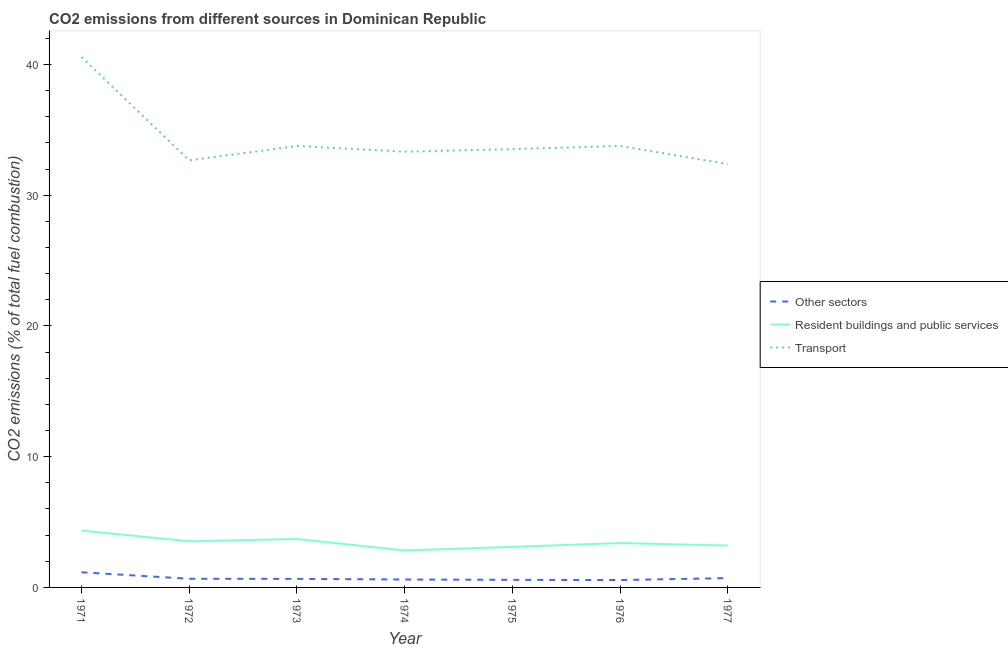Does the line corresponding to percentage of co2 emissions from transport intersect with the line corresponding to percentage of co2 emissions from other sectors?
Ensure brevity in your answer.  No. What is the percentage of co2 emissions from resident buildings and public services in 1972?
Provide a succinct answer. 3.53. Across all years, what is the maximum percentage of co2 emissions from resident buildings and public services?
Offer a terse response. 4.35. Across all years, what is the minimum percentage of co2 emissions from other sectors?
Offer a terse response. 0.57. In which year was the percentage of co2 emissions from transport minimum?
Provide a succinct answer. 1977. What is the total percentage of co2 emissions from transport in the graph?
Provide a short and direct response. 240.04. What is the difference between the percentage of co2 emissions from transport in 1974 and that in 1977?
Provide a short and direct response. 0.95. What is the difference between the percentage of co2 emissions from transport in 1971 and the percentage of co2 emissions from other sectors in 1973?
Keep it short and to the point. 39.93. What is the average percentage of co2 emissions from resident buildings and public services per year?
Keep it short and to the point. 3.44. In the year 1973, what is the difference between the percentage of co2 emissions from resident buildings and public services and percentage of co2 emissions from other sectors?
Give a very brief answer. 3.05. What is the ratio of the percentage of co2 emissions from transport in 1972 to that in 1974?
Provide a short and direct response. 0.98. Is the difference between the percentage of co2 emissions from resident buildings and public services in 1975 and 1976 greater than the difference between the percentage of co2 emissions from transport in 1975 and 1976?
Your response must be concise. No. What is the difference between the highest and the second highest percentage of co2 emissions from resident buildings and public services?
Offer a terse response. 0.64. What is the difference between the highest and the lowest percentage of co2 emissions from other sectors?
Ensure brevity in your answer.  0.59. In how many years, is the percentage of co2 emissions from transport greater than the average percentage of co2 emissions from transport taken over all years?
Your answer should be compact. 1. Is the sum of the percentage of co2 emissions from other sectors in 1971 and 1977 greater than the maximum percentage of co2 emissions from resident buildings and public services across all years?
Keep it short and to the point. No. Is it the case that in every year, the sum of the percentage of co2 emissions from other sectors and percentage of co2 emissions from resident buildings and public services is greater than the percentage of co2 emissions from transport?
Ensure brevity in your answer.  No. Is the percentage of co2 emissions from resident buildings and public services strictly greater than the percentage of co2 emissions from other sectors over the years?
Give a very brief answer. Yes. How many lines are there?
Offer a terse response. 3. How many years are there in the graph?
Offer a very short reply. 7. Are the values on the major ticks of Y-axis written in scientific E-notation?
Provide a succinct answer. No. Does the graph contain any zero values?
Your answer should be compact. No. Does the graph contain grids?
Your response must be concise. No. Where does the legend appear in the graph?
Offer a terse response. Center right. How are the legend labels stacked?
Give a very brief answer. Vertical. What is the title of the graph?
Offer a terse response. CO2 emissions from different sources in Dominican Republic. What is the label or title of the Y-axis?
Provide a succinct answer. CO2 emissions (% of total fuel combustion). What is the CO2 emissions (% of total fuel combustion) in Other sectors in 1971?
Keep it short and to the point. 1.16. What is the CO2 emissions (% of total fuel combustion) in Resident buildings and public services in 1971?
Keep it short and to the point. 4.35. What is the CO2 emissions (% of total fuel combustion) in Transport in 1971?
Your answer should be very brief. 40.58. What is the CO2 emissions (% of total fuel combustion) of Other sectors in 1972?
Provide a short and direct response. 0.66. What is the CO2 emissions (% of total fuel combustion) of Resident buildings and public services in 1972?
Your response must be concise. 3.53. What is the CO2 emissions (% of total fuel combustion) in Transport in 1972?
Offer a terse response. 32.67. What is the CO2 emissions (% of total fuel combustion) of Other sectors in 1973?
Provide a short and direct response. 0.65. What is the CO2 emissions (% of total fuel combustion) in Resident buildings and public services in 1973?
Give a very brief answer. 3.7. What is the CO2 emissions (% of total fuel combustion) of Transport in 1973?
Ensure brevity in your answer.  33.77. What is the CO2 emissions (% of total fuel combustion) of Other sectors in 1974?
Ensure brevity in your answer.  0.61. What is the CO2 emissions (% of total fuel combustion) in Resident buildings and public services in 1974?
Ensure brevity in your answer.  2.83. What is the CO2 emissions (% of total fuel combustion) in Transport in 1974?
Offer a very short reply. 33.33. What is the CO2 emissions (% of total fuel combustion) in Other sectors in 1975?
Offer a very short reply. 0.58. What is the CO2 emissions (% of total fuel combustion) of Resident buildings and public services in 1975?
Keep it short and to the point. 3.1. What is the CO2 emissions (% of total fuel combustion) of Transport in 1975?
Provide a succinct answer. 33.53. What is the CO2 emissions (% of total fuel combustion) of Other sectors in 1976?
Your answer should be very brief. 0.57. What is the CO2 emissions (% of total fuel combustion) in Resident buildings and public services in 1976?
Give a very brief answer. 3.4. What is the CO2 emissions (% of total fuel combustion) of Transport in 1976?
Keep it short and to the point. 33.77. What is the CO2 emissions (% of total fuel combustion) of Other sectors in 1977?
Provide a succinct answer. 0.71. What is the CO2 emissions (% of total fuel combustion) of Resident buildings and public services in 1977?
Your response must be concise. 3.2. What is the CO2 emissions (% of total fuel combustion) in Transport in 1977?
Provide a succinct answer. 32.38. Across all years, what is the maximum CO2 emissions (% of total fuel combustion) in Other sectors?
Give a very brief answer. 1.16. Across all years, what is the maximum CO2 emissions (% of total fuel combustion) of Resident buildings and public services?
Your answer should be compact. 4.35. Across all years, what is the maximum CO2 emissions (% of total fuel combustion) of Transport?
Ensure brevity in your answer.  40.58. Across all years, what is the minimum CO2 emissions (% of total fuel combustion) of Other sectors?
Give a very brief answer. 0.57. Across all years, what is the minimum CO2 emissions (% of total fuel combustion) in Resident buildings and public services?
Offer a very short reply. 2.83. Across all years, what is the minimum CO2 emissions (% of total fuel combustion) of Transport?
Offer a very short reply. 32.38. What is the total CO2 emissions (% of total fuel combustion) in Other sectors in the graph?
Offer a very short reply. 4.94. What is the total CO2 emissions (% of total fuel combustion) of Resident buildings and public services in the graph?
Your answer should be compact. 24.11. What is the total CO2 emissions (% of total fuel combustion) in Transport in the graph?
Provide a short and direct response. 240.04. What is the difference between the CO2 emissions (% of total fuel combustion) of Other sectors in 1971 and that in 1972?
Offer a very short reply. 0.5. What is the difference between the CO2 emissions (% of total fuel combustion) of Resident buildings and public services in 1971 and that in 1972?
Keep it short and to the point. 0.82. What is the difference between the CO2 emissions (% of total fuel combustion) of Transport in 1971 and that in 1972?
Your answer should be very brief. 7.91. What is the difference between the CO2 emissions (% of total fuel combustion) of Other sectors in 1971 and that in 1973?
Your response must be concise. 0.51. What is the difference between the CO2 emissions (% of total fuel combustion) of Resident buildings and public services in 1971 and that in 1973?
Provide a short and direct response. 0.64. What is the difference between the CO2 emissions (% of total fuel combustion) of Transport in 1971 and that in 1973?
Provide a short and direct response. 6.81. What is the difference between the CO2 emissions (% of total fuel combustion) in Other sectors in 1971 and that in 1974?
Your answer should be very brief. 0.55. What is the difference between the CO2 emissions (% of total fuel combustion) of Resident buildings and public services in 1971 and that in 1974?
Provide a short and direct response. 1.52. What is the difference between the CO2 emissions (% of total fuel combustion) in Transport in 1971 and that in 1974?
Your answer should be very brief. 7.25. What is the difference between the CO2 emissions (% of total fuel combustion) in Other sectors in 1971 and that in 1975?
Provide a succinct answer. 0.58. What is the difference between the CO2 emissions (% of total fuel combustion) of Resident buildings and public services in 1971 and that in 1975?
Your answer should be very brief. 1.25. What is the difference between the CO2 emissions (% of total fuel combustion) in Transport in 1971 and that in 1975?
Give a very brief answer. 7.05. What is the difference between the CO2 emissions (% of total fuel combustion) in Other sectors in 1971 and that in 1976?
Offer a terse response. 0.59. What is the difference between the CO2 emissions (% of total fuel combustion) of Resident buildings and public services in 1971 and that in 1976?
Make the answer very short. 0.95. What is the difference between the CO2 emissions (% of total fuel combustion) in Transport in 1971 and that in 1976?
Offer a terse response. 6.81. What is the difference between the CO2 emissions (% of total fuel combustion) in Other sectors in 1971 and that in 1977?
Make the answer very short. 0.45. What is the difference between the CO2 emissions (% of total fuel combustion) in Resident buildings and public services in 1971 and that in 1977?
Your answer should be very brief. 1.15. What is the difference between the CO2 emissions (% of total fuel combustion) in Transport in 1971 and that in 1977?
Give a very brief answer. 8.2. What is the difference between the CO2 emissions (% of total fuel combustion) in Other sectors in 1972 and that in 1973?
Your answer should be compact. 0.01. What is the difference between the CO2 emissions (% of total fuel combustion) in Resident buildings and public services in 1972 and that in 1973?
Give a very brief answer. -0.17. What is the difference between the CO2 emissions (% of total fuel combustion) of Transport in 1972 and that in 1973?
Your answer should be compact. -1.1. What is the difference between the CO2 emissions (% of total fuel combustion) of Other sectors in 1972 and that in 1974?
Ensure brevity in your answer.  0.06. What is the difference between the CO2 emissions (% of total fuel combustion) in Resident buildings and public services in 1972 and that in 1974?
Ensure brevity in your answer.  0.7. What is the difference between the CO2 emissions (% of total fuel combustion) in Transport in 1972 and that in 1974?
Ensure brevity in your answer.  -0.66. What is the difference between the CO2 emissions (% of total fuel combustion) in Other sectors in 1972 and that in 1975?
Make the answer very short. 0.08. What is the difference between the CO2 emissions (% of total fuel combustion) of Resident buildings and public services in 1972 and that in 1975?
Provide a short and direct response. 0.43. What is the difference between the CO2 emissions (% of total fuel combustion) of Transport in 1972 and that in 1975?
Give a very brief answer. -0.86. What is the difference between the CO2 emissions (% of total fuel combustion) of Other sectors in 1972 and that in 1976?
Offer a very short reply. 0.1. What is the difference between the CO2 emissions (% of total fuel combustion) in Resident buildings and public services in 1972 and that in 1976?
Your answer should be very brief. 0.14. What is the difference between the CO2 emissions (% of total fuel combustion) of Transport in 1972 and that in 1976?
Your response must be concise. -1.1. What is the difference between the CO2 emissions (% of total fuel combustion) of Other sectors in 1972 and that in 1977?
Give a very brief answer. -0.05. What is the difference between the CO2 emissions (% of total fuel combustion) of Resident buildings and public services in 1972 and that in 1977?
Offer a very short reply. 0.33. What is the difference between the CO2 emissions (% of total fuel combustion) of Transport in 1972 and that in 1977?
Give a very brief answer. 0.29. What is the difference between the CO2 emissions (% of total fuel combustion) of Other sectors in 1973 and that in 1974?
Provide a succinct answer. 0.05. What is the difference between the CO2 emissions (% of total fuel combustion) in Resident buildings and public services in 1973 and that in 1974?
Keep it short and to the point. 0.88. What is the difference between the CO2 emissions (% of total fuel combustion) of Transport in 1973 and that in 1974?
Your answer should be compact. 0.44. What is the difference between the CO2 emissions (% of total fuel combustion) in Other sectors in 1973 and that in 1975?
Offer a terse response. 0.07. What is the difference between the CO2 emissions (% of total fuel combustion) in Resident buildings and public services in 1973 and that in 1975?
Your answer should be very brief. 0.6. What is the difference between the CO2 emissions (% of total fuel combustion) in Transport in 1973 and that in 1975?
Offer a very short reply. 0.24. What is the difference between the CO2 emissions (% of total fuel combustion) of Other sectors in 1973 and that in 1976?
Your answer should be compact. 0.09. What is the difference between the CO2 emissions (% of total fuel combustion) in Resident buildings and public services in 1973 and that in 1976?
Offer a terse response. 0.31. What is the difference between the CO2 emissions (% of total fuel combustion) of Transport in 1973 and that in 1976?
Ensure brevity in your answer.  -0. What is the difference between the CO2 emissions (% of total fuel combustion) of Other sectors in 1973 and that in 1977?
Provide a succinct answer. -0.06. What is the difference between the CO2 emissions (% of total fuel combustion) in Resident buildings and public services in 1973 and that in 1977?
Your response must be concise. 0.5. What is the difference between the CO2 emissions (% of total fuel combustion) of Transport in 1973 and that in 1977?
Provide a short and direct response. 1.38. What is the difference between the CO2 emissions (% of total fuel combustion) in Other sectors in 1974 and that in 1975?
Give a very brief answer. 0.02. What is the difference between the CO2 emissions (% of total fuel combustion) of Resident buildings and public services in 1974 and that in 1975?
Ensure brevity in your answer.  -0.27. What is the difference between the CO2 emissions (% of total fuel combustion) in Transport in 1974 and that in 1975?
Offer a terse response. -0.19. What is the difference between the CO2 emissions (% of total fuel combustion) of Resident buildings and public services in 1974 and that in 1976?
Provide a short and direct response. -0.57. What is the difference between the CO2 emissions (% of total fuel combustion) in Transport in 1974 and that in 1976?
Offer a terse response. -0.44. What is the difference between the CO2 emissions (% of total fuel combustion) in Other sectors in 1974 and that in 1977?
Ensure brevity in your answer.  -0.11. What is the difference between the CO2 emissions (% of total fuel combustion) in Resident buildings and public services in 1974 and that in 1977?
Offer a terse response. -0.37. What is the difference between the CO2 emissions (% of total fuel combustion) in Transport in 1974 and that in 1977?
Give a very brief answer. 0.95. What is the difference between the CO2 emissions (% of total fuel combustion) in Other sectors in 1975 and that in 1976?
Your response must be concise. 0.02. What is the difference between the CO2 emissions (% of total fuel combustion) in Resident buildings and public services in 1975 and that in 1976?
Ensure brevity in your answer.  -0.3. What is the difference between the CO2 emissions (% of total fuel combustion) of Transport in 1975 and that in 1976?
Your answer should be compact. -0.25. What is the difference between the CO2 emissions (% of total fuel combustion) in Other sectors in 1975 and that in 1977?
Keep it short and to the point. -0.13. What is the difference between the CO2 emissions (% of total fuel combustion) of Resident buildings and public services in 1975 and that in 1977?
Keep it short and to the point. -0.1. What is the difference between the CO2 emissions (% of total fuel combustion) of Transport in 1975 and that in 1977?
Your response must be concise. 1.14. What is the difference between the CO2 emissions (% of total fuel combustion) of Other sectors in 1976 and that in 1977?
Provide a short and direct response. -0.15. What is the difference between the CO2 emissions (% of total fuel combustion) of Resident buildings and public services in 1976 and that in 1977?
Your response must be concise. 0.19. What is the difference between the CO2 emissions (% of total fuel combustion) of Transport in 1976 and that in 1977?
Make the answer very short. 1.39. What is the difference between the CO2 emissions (% of total fuel combustion) of Other sectors in 1971 and the CO2 emissions (% of total fuel combustion) of Resident buildings and public services in 1972?
Your answer should be compact. -2.37. What is the difference between the CO2 emissions (% of total fuel combustion) of Other sectors in 1971 and the CO2 emissions (% of total fuel combustion) of Transport in 1972?
Ensure brevity in your answer.  -31.51. What is the difference between the CO2 emissions (% of total fuel combustion) in Resident buildings and public services in 1971 and the CO2 emissions (% of total fuel combustion) in Transport in 1972?
Your response must be concise. -28.32. What is the difference between the CO2 emissions (% of total fuel combustion) in Other sectors in 1971 and the CO2 emissions (% of total fuel combustion) in Resident buildings and public services in 1973?
Your answer should be very brief. -2.54. What is the difference between the CO2 emissions (% of total fuel combustion) of Other sectors in 1971 and the CO2 emissions (% of total fuel combustion) of Transport in 1973?
Your answer should be compact. -32.61. What is the difference between the CO2 emissions (% of total fuel combustion) of Resident buildings and public services in 1971 and the CO2 emissions (% of total fuel combustion) of Transport in 1973?
Your response must be concise. -29.42. What is the difference between the CO2 emissions (% of total fuel combustion) in Other sectors in 1971 and the CO2 emissions (% of total fuel combustion) in Resident buildings and public services in 1974?
Make the answer very short. -1.67. What is the difference between the CO2 emissions (% of total fuel combustion) of Other sectors in 1971 and the CO2 emissions (% of total fuel combustion) of Transport in 1974?
Keep it short and to the point. -32.17. What is the difference between the CO2 emissions (% of total fuel combustion) in Resident buildings and public services in 1971 and the CO2 emissions (% of total fuel combustion) in Transport in 1974?
Give a very brief answer. -28.99. What is the difference between the CO2 emissions (% of total fuel combustion) of Other sectors in 1971 and the CO2 emissions (% of total fuel combustion) of Resident buildings and public services in 1975?
Provide a succinct answer. -1.94. What is the difference between the CO2 emissions (% of total fuel combustion) of Other sectors in 1971 and the CO2 emissions (% of total fuel combustion) of Transport in 1975?
Give a very brief answer. -32.37. What is the difference between the CO2 emissions (% of total fuel combustion) of Resident buildings and public services in 1971 and the CO2 emissions (% of total fuel combustion) of Transport in 1975?
Offer a terse response. -29.18. What is the difference between the CO2 emissions (% of total fuel combustion) in Other sectors in 1971 and the CO2 emissions (% of total fuel combustion) in Resident buildings and public services in 1976?
Your answer should be compact. -2.24. What is the difference between the CO2 emissions (% of total fuel combustion) in Other sectors in 1971 and the CO2 emissions (% of total fuel combustion) in Transport in 1976?
Offer a terse response. -32.61. What is the difference between the CO2 emissions (% of total fuel combustion) in Resident buildings and public services in 1971 and the CO2 emissions (% of total fuel combustion) in Transport in 1976?
Provide a short and direct response. -29.43. What is the difference between the CO2 emissions (% of total fuel combustion) in Other sectors in 1971 and the CO2 emissions (% of total fuel combustion) in Resident buildings and public services in 1977?
Ensure brevity in your answer.  -2.04. What is the difference between the CO2 emissions (% of total fuel combustion) of Other sectors in 1971 and the CO2 emissions (% of total fuel combustion) of Transport in 1977?
Provide a succinct answer. -31.22. What is the difference between the CO2 emissions (% of total fuel combustion) in Resident buildings and public services in 1971 and the CO2 emissions (% of total fuel combustion) in Transport in 1977?
Offer a very short reply. -28.04. What is the difference between the CO2 emissions (% of total fuel combustion) of Other sectors in 1972 and the CO2 emissions (% of total fuel combustion) of Resident buildings and public services in 1973?
Give a very brief answer. -3.04. What is the difference between the CO2 emissions (% of total fuel combustion) in Other sectors in 1972 and the CO2 emissions (% of total fuel combustion) in Transport in 1973?
Your response must be concise. -33.11. What is the difference between the CO2 emissions (% of total fuel combustion) of Resident buildings and public services in 1972 and the CO2 emissions (% of total fuel combustion) of Transport in 1973?
Ensure brevity in your answer.  -30.24. What is the difference between the CO2 emissions (% of total fuel combustion) of Other sectors in 1972 and the CO2 emissions (% of total fuel combustion) of Resident buildings and public services in 1974?
Your answer should be compact. -2.17. What is the difference between the CO2 emissions (% of total fuel combustion) in Other sectors in 1972 and the CO2 emissions (% of total fuel combustion) in Transport in 1974?
Ensure brevity in your answer.  -32.67. What is the difference between the CO2 emissions (% of total fuel combustion) in Resident buildings and public services in 1972 and the CO2 emissions (% of total fuel combustion) in Transport in 1974?
Provide a succinct answer. -29.8. What is the difference between the CO2 emissions (% of total fuel combustion) in Other sectors in 1972 and the CO2 emissions (% of total fuel combustion) in Resident buildings and public services in 1975?
Your response must be concise. -2.44. What is the difference between the CO2 emissions (% of total fuel combustion) in Other sectors in 1972 and the CO2 emissions (% of total fuel combustion) in Transport in 1975?
Offer a very short reply. -32.86. What is the difference between the CO2 emissions (% of total fuel combustion) of Resident buildings and public services in 1972 and the CO2 emissions (% of total fuel combustion) of Transport in 1975?
Provide a succinct answer. -30. What is the difference between the CO2 emissions (% of total fuel combustion) in Other sectors in 1972 and the CO2 emissions (% of total fuel combustion) in Resident buildings and public services in 1976?
Make the answer very short. -2.73. What is the difference between the CO2 emissions (% of total fuel combustion) in Other sectors in 1972 and the CO2 emissions (% of total fuel combustion) in Transport in 1976?
Provide a succinct answer. -33.11. What is the difference between the CO2 emissions (% of total fuel combustion) in Resident buildings and public services in 1972 and the CO2 emissions (% of total fuel combustion) in Transport in 1976?
Provide a short and direct response. -30.24. What is the difference between the CO2 emissions (% of total fuel combustion) of Other sectors in 1972 and the CO2 emissions (% of total fuel combustion) of Resident buildings and public services in 1977?
Give a very brief answer. -2.54. What is the difference between the CO2 emissions (% of total fuel combustion) of Other sectors in 1972 and the CO2 emissions (% of total fuel combustion) of Transport in 1977?
Offer a very short reply. -31.72. What is the difference between the CO2 emissions (% of total fuel combustion) of Resident buildings and public services in 1972 and the CO2 emissions (% of total fuel combustion) of Transport in 1977?
Provide a short and direct response. -28.85. What is the difference between the CO2 emissions (% of total fuel combustion) in Other sectors in 1973 and the CO2 emissions (% of total fuel combustion) in Resident buildings and public services in 1974?
Give a very brief answer. -2.17. What is the difference between the CO2 emissions (% of total fuel combustion) in Other sectors in 1973 and the CO2 emissions (% of total fuel combustion) in Transport in 1974?
Offer a terse response. -32.68. What is the difference between the CO2 emissions (% of total fuel combustion) of Resident buildings and public services in 1973 and the CO2 emissions (% of total fuel combustion) of Transport in 1974?
Your response must be concise. -29.63. What is the difference between the CO2 emissions (% of total fuel combustion) in Other sectors in 1973 and the CO2 emissions (% of total fuel combustion) in Resident buildings and public services in 1975?
Your response must be concise. -2.45. What is the difference between the CO2 emissions (% of total fuel combustion) of Other sectors in 1973 and the CO2 emissions (% of total fuel combustion) of Transport in 1975?
Provide a succinct answer. -32.87. What is the difference between the CO2 emissions (% of total fuel combustion) in Resident buildings and public services in 1973 and the CO2 emissions (% of total fuel combustion) in Transport in 1975?
Make the answer very short. -29.82. What is the difference between the CO2 emissions (% of total fuel combustion) in Other sectors in 1973 and the CO2 emissions (% of total fuel combustion) in Resident buildings and public services in 1976?
Your response must be concise. -2.74. What is the difference between the CO2 emissions (% of total fuel combustion) of Other sectors in 1973 and the CO2 emissions (% of total fuel combustion) of Transport in 1976?
Provide a short and direct response. -33.12. What is the difference between the CO2 emissions (% of total fuel combustion) of Resident buildings and public services in 1973 and the CO2 emissions (% of total fuel combustion) of Transport in 1976?
Your response must be concise. -30.07. What is the difference between the CO2 emissions (% of total fuel combustion) of Other sectors in 1973 and the CO2 emissions (% of total fuel combustion) of Resident buildings and public services in 1977?
Your answer should be compact. -2.55. What is the difference between the CO2 emissions (% of total fuel combustion) of Other sectors in 1973 and the CO2 emissions (% of total fuel combustion) of Transport in 1977?
Give a very brief answer. -31.73. What is the difference between the CO2 emissions (% of total fuel combustion) of Resident buildings and public services in 1973 and the CO2 emissions (% of total fuel combustion) of Transport in 1977?
Make the answer very short. -28.68. What is the difference between the CO2 emissions (% of total fuel combustion) in Other sectors in 1974 and the CO2 emissions (% of total fuel combustion) in Resident buildings and public services in 1975?
Offer a terse response. -2.49. What is the difference between the CO2 emissions (% of total fuel combustion) in Other sectors in 1974 and the CO2 emissions (% of total fuel combustion) in Transport in 1975?
Offer a very short reply. -32.92. What is the difference between the CO2 emissions (% of total fuel combustion) in Resident buildings and public services in 1974 and the CO2 emissions (% of total fuel combustion) in Transport in 1975?
Keep it short and to the point. -30.7. What is the difference between the CO2 emissions (% of total fuel combustion) of Other sectors in 1974 and the CO2 emissions (% of total fuel combustion) of Resident buildings and public services in 1976?
Offer a terse response. -2.79. What is the difference between the CO2 emissions (% of total fuel combustion) of Other sectors in 1974 and the CO2 emissions (% of total fuel combustion) of Transport in 1976?
Give a very brief answer. -33.17. What is the difference between the CO2 emissions (% of total fuel combustion) of Resident buildings and public services in 1974 and the CO2 emissions (% of total fuel combustion) of Transport in 1976?
Provide a short and direct response. -30.95. What is the difference between the CO2 emissions (% of total fuel combustion) in Other sectors in 1974 and the CO2 emissions (% of total fuel combustion) in Resident buildings and public services in 1977?
Offer a very short reply. -2.6. What is the difference between the CO2 emissions (% of total fuel combustion) of Other sectors in 1974 and the CO2 emissions (% of total fuel combustion) of Transport in 1977?
Ensure brevity in your answer.  -31.78. What is the difference between the CO2 emissions (% of total fuel combustion) of Resident buildings and public services in 1974 and the CO2 emissions (% of total fuel combustion) of Transport in 1977?
Keep it short and to the point. -29.56. What is the difference between the CO2 emissions (% of total fuel combustion) in Other sectors in 1975 and the CO2 emissions (% of total fuel combustion) in Resident buildings and public services in 1976?
Your answer should be very brief. -2.81. What is the difference between the CO2 emissions (% of total fuel combustion) in Other sectors in 1975 and the CO2 emissions (% of total fuel combustion) in Transport in 1976?
Ensure brevity in your answer.  -33.19. What is the difference between the CO2 emissions (% of total fuel combustion) of Resident buildings and public services in 1975 and the CO2 emissions (% of total fuel combustion) of Transport in 1976?
Make the answer very short. -30.67. What is the difference between the CO2 emissions (% of total fuel combustion) of Other sectors in 1975 and the CO2 emissions (% of total fuel combustion) of Resident buildings and public services in 1977?
Your answer should be very brief. -2.62. What is the difference between the CO2 emissions (% of total fuel combustion) in Other sectors in 1975 and the CO2 emissions (% of total fuel combustion) in Transport in 1977?
Your answer should be very brief. -31.8. What is the difference between the CO2 emissions (% of total fuel combustion) of Resident buildings and public services in 1975 and the CO2 emissions (% of total fuel combustion) of Transport in 1977?
Your answer should be compact. -29.28. What is the difference between the CO2 emissions (% of total fuel combustion) of Other sectors in 1976 and the CO2 emissions (% of total fuel combustion) of Resident buildings and public services in 1977?
Your answer should be very brief. -2.64. What is the difference between the CO2 emissions (% of total fuel combustion) in Other sectors in 1976 and the CO2 emissions (% of total fuel combustion) in Transport in 1977?
Your answer should be compact. -31.82. What is the difference between the CO2 emissions (% of total fuel combustion) in Resident buildings and public services in 1976 and the CO2 emissions (% of total fuel combustion) in Transport in 1977?
Your answer should be compact. -28.99. What is the average CO2 emissions (% of total fuel combustion) in Other sectors per year?
Your response must be concise. 0.71. What is the average CO2 emissions (% of total fuel combustion) of Resident buildings and public services per year?
Provide a succinct answer. 3.44. What is the average CO2 emissions (% of total fuel combustion) in Transport per year?
Ensure brevity in your answer.  34.29. In the year 1971, what is the difference between the CO2 emissions (% of total fuel combustion) in Other sectors and CO2 emissions (% of total fuel combustion) in Resident buildings and public services?
Give a very brief answer. -3.19. In the year 1971, what is the difference between the CO2 emissions (% of total fuel combustion) in Other sectors and CO2 emissions (% of total fuel combustion) in Transport?
Give a very brief answer. -39.42. In the year 1971, what is the difference between the CO2 emissions (% of total fuel combustion) of Resident buildings and public services and CO2 emissions (% of total fuel combustion) of Transport?
Your response must be concise. -36.23. In the year 1972, what is the difference between the CO2 emissions (% of total fuel combustion) in Other sectors and CO2 emissions (% of total fuel combustion) in Resident buildings and public services?
Your answer should be very brief. -2.87. In the year 1972, what is the difference between the CO2 emissions (% of total fuel combustion) of Other sectors and CO2 emissions (% of total fuel combustion) of Transport?
Your answer should be compact. -32.01. In the year 1972, what is the difference between the CO2 emissions (% of total fuel combustion) in Resident buildings and public services and CO2 emissions (% of total fuel combustion) in Transport?
Your answer should be very brief. -29.14. In the year 1973, what is the difference between the CO2 emissions (% of total fuel combustion) of Other sectors and CO2 emissions (% of total fuel combustion) of Resident buildings and public services?
Offer a very short reply. -3.05. In the year 1973, what is the difference between the CO2 emissions (% of total fuel combustion) in Other sectors and CO2 emissions (% of total fuel combustion) in Transport?
Provide a short and direct response. -33.12. In the year 1973, what is the difference between the CO2 emissions (% of total fuel combustion) in Resident buildings and public services and CO2 emissions (% of total fuel combustion) in Transport?
Give a very brief answer. -30.07. In the year 1974, what is the difference between the CO2 emissions (% of total fuel combustion) of Other sectors and CO2 emissions (% of total fuel combustion) of Resident buildings and public services?
Ensure brevity in your answer.  -2.22. In the year 1974, what is the difference between the CO2 emissions (% of total fuel combustion) of Other sectors and CO2 emissions (% of total fuel combustion) of Transport?
Provide a short and direct response. -32.73. In the year 1974, what is the difference between the CO2 emissions (% of total fuel combustion) in Resident buildings and public services and CO2 emissions (% of total fuel combustion) in Transport?
Offer a very short reply. -30.51. In the year 1975, what is the difference between the CO2 emissions (% of total fuel combustion) in Other sectors and CO2 emissions (% of total fuel combustion) in Resident buildings and public services?
Your answer should be compact. -2.52. In the year 1975, what is the difference between the CO2 emissions (% of total fuel combustion) of Other sectors and CO2 emissions (% of total fuel combustion) of Transport?
Ensure brevity in your answer.  -32.95. In the year 1975, what is the difference between the CO2 emissions (% of total fuel combustion) of Resident buildings and public services and CO2 emissions (% of total fuel combustion) of Transport?
Your answer should be compact. -30.43. In the year 1976, what is the difference between the CO2 emissions (% of total fuel combustion) in Other sectors and CO2 emissions (% of total fuel combustion) in Resident buildings and public services?
Provide a succinct answer. -2.83. In the year 1976, what is the difference between the CO2 emissions (% of total fuel combustion) in Other sectors and CO2 emissions (% of total fuel combustion) in Transport?
Offer a terse response. -33.21. In the year 1976, what is the difference between the CO2 emissions (% of total fuel combustion) of Resident buildings and public services and CO2 emissions (% of total fuel combustion) of Transport?
Offer a very short reply. -30.38. In the year 1977, what is the difference between the CO2 emissions (% of total fuel combustion) of Other sectors and CO2 emissions (% of total fuel combustion) of Resident buildings and public services?
Offer a terse response. -2.49. In the year 1977, what is the difference between the CO2 emissions (% of total fuel combustion) in Other sectors and CO2 emissions (% of total fuel combustion) in Transport?
Offer a terse response. -31.67. In the year 1977, what is the difference between the CO2 emissions (% of total fuel combustion) of Resident buildings and public services and CO2 emissions (% of total fuel combustion) of Transport?
Your answer should be compact. -29.18. What is the ratio of the CO2 emissions (% of total fuel combustion) of Other sectors in 1971 to that in 1972?
Make the answer very short. 1.75. What is the ratio of the CO2 emissions (% of total fuel combustion) of Resident buildings and public services in 1971 to that in 1972?
Give a very brief answer. 1.23. What is the ratio of the CO2 emissions (% of total fuel combustion) of Transport in 1971 to that in 1972?
Give a very brief answer. 1.24. What is the ratio of the CO2 emissions (% of total fuel combustion) of Other sectors in 1971 to that in 1973?
Make the answer very short. 1.77. What is the ratio of the CO2 emissions (% of total fuel combustion) of Resident buildings and public services in 1971 to that in 1973?
Keep it short and to the point. 1.17. What is the ratio of the CO2 emissions (% of total fuel combustion) of Transport in 1971 to that in 1973?
Your response must be concise. 1.2. What is the ratio of the CO2 emissions (% of total fuel combustion) in Other sectors in 1971 to that in 1974?
Provide a short and direct response. 1.91. What is the ratio of the CO2 emissions (% of total fuel combustion) in Resident buildings and public services in 1971 to that in 1974?
Offer a very short reply. 1.54. What is the ratio of the CO2 emissions (% of total fuel combustion) in Transport in 1971 to that in 1974?
Keep it short and to the point. 1.22. What is the ratio of the CO2 emissions (% of total fuel combustion) of Other sectors in 1971 to that in 1975?
Offer a terse response. 1.99. What is the ratio of the CO2 emissions (% of total fuel combustion) of Resident buildings and public services in 1971 to that in 1975?
Your answer should be compact. 1.4. What is the ratio of the CO2 emissions (% of total fuel combustion) in Transport in 1971 to that in 1975?
Your answer should be very brief. 1.21. What is the ratio of the CO2 emissions (% of total fuel combustion) of Other sectors in 1971 to that in 1976?
Provide a short and direct response. 2.05. What is the ratio of the CO2 emissions (% of total fuel combustion) in Resident buildings and public services in 1971 to that in 1976?
Offer a very short reply. 1.28. What is the ratio of the CO2 emissions (% of total fuel combustion) in Transport in 1971 to that in 1976?
Provide a succinct answer. 1.2. What is the ratio of the CO2 emissions (% of total fuel combustion) of Other sectors in 1971 to that in 1977?
Offer a very short reply. 1.63. What is the ratio of the CO2 emissions (% of total fuel combustion) of Resident buildings and public services in 1971 to that in 1977?
Keep it short and to the point. 1.36. What is the ratio of the CO2 emissions (% of total fuel combustion) of Transport in 1971 to that in 1977?
Offer a very short reply. 1.25. What is the ratio of the CO2 emissions (% of total fuel combustion) in Other sectors in 1972 to that in 1973?
Offer a very short reply. 1.01. What is the ratio of the CO2 emissions (% of total fuel combustion) in Resident buildings and public services in 1972 to that in 1973?
Your response must be concise. 0.95. What is the ratio of the CO2 emissions (% of total fuel combustion) in Transport in 1972 to that in 1973?
Provide a short and direct response. 0.97. What is the ratio of the CO2 emissions (% of total fuel combustion) in Other sectors in 1972 to that in 1974?
Your response must be concise. 1.09. What is the ratio of the CO2 emissions (% of total fuel combustion) of Resident buildings and public services in 1972 to that in 1974?
Your answer should be very brief. 1.25. What is the ratio of the CO2 emissions (% of total fuel combustion) in Transport in 1972 to that in 1974?
Offer a very short reply. 0.98. What is the ratio of the CO2 emissions (% of total fuel combustion) of Other sectors in 1972 to that in 1975?
Provide a short and direct response. 1.14. What is the ratio of the CO2 emissions (% of total fuel combustion) of Resident buildings and public services in 1972 to that in 1975?
Your response must be concise. 1.14. What is the ratio of the CO2 emissions (% of total fuel combustion) in Transport in 1972 to that in 1975?
Offer a terse response. 0.97. What is the ratio of the CO2 emissions (% of total fuel combustion) of Other sectors in 1972 to that in 1976?
Your answer should be very brief. 1.17. What is the ratio of the CO2 emissions (% of total fuel combustion) of Resident buildings and public services in 1972 to that in 1976?
Your response must be concise. 1.04. What is the ratio of the CO2 emissions (% of total fuel combustion) in Transport in 1972 to that in 1976?
Your answer should be compact. 0.97. What is the ratio of the CO2 emissions (% of total fuel combustion) of Other sectors in 1972 to that in 1977?
Offer a terse response. 0.93. What is the ratio of the CO2 emissions (% of total fuel combustion) of Resident buildings and public services in 1972 to that in 1977?
Keep it short and to the point. 1.1. What is the ratio of the CO2 emissions (% of total fuel combustion) of Transport in 1972 to that in 1977?
Provide a succinct answer. 1.01. What is the ratio of the CO2 emissions (% of total fuel combustion) of Other sectors in 1973 to that in 1974?
Offer a terse response. 1.08. What is the ratio of the CO2 emissions (% of total fuel combustion) in Resident buildings and public services in 1973 to that in 1974?
Give a very brief answer. 1.31. What is the ratio of the CO2 emissions (% of total fuel combustion) of Transport in 1973 to that in 1974?
Your response must be concise. 1.01. What is the ratio of the CO2 emissions (% of total fuel combustion) in Other sectors in 1973 to that in 1975?
Ensure brevity in your answer.  1.12. What is the ratio of the CO2 emissions (% of total fuel combustion) of Resident buildings and public services in 1973 to that in 1975?
Your response must be concise. 1.19. What is the ratio of the CO2 emissions (% of total fuel combustion) of Other sectors in 1973 to that in 1976?
Your answer should be compact. 1.15. What is the ratio of the CO2 emissions (% of total fuel combustion) of Resident buildings and public services in 1973 to that in 1976?
Your answer should be compact. 1.09. What is the ratio of the CO2 emissions (% of total fuel combustion) in Other sectors in 1973 to that in 1977?
Make the answer very short. 0.92. What is the ratio of the CO2 emissions (% of total fuel combustion) of Resident buildings and public services in 1973 to that in 1977?
Offer a very short reply. 1.16. What is the ratio of the CO2 emissions (% of total fuel combustion) of Transport in 1973 to that in 1977?
Give a very brief answer. 1.04. What is the ratio of the CO2 emissions (% of total fuel combustion) in Other sectors in 1974 to that in 1975?
Offer a terse response. 1.04. What is the ratio of the CO2 emissions (% of total fuel combustion) in Resident buildings and public services in 1974 to that in 1975?
Keep it short and to the point. 0.91. What is the ratio of the CO2 emissions (% of total fuel combustion) in Other sectors in 1974 to that in 1976?
Ensure brevity in your answer.  1.07. What is the ratio of the CO2 emissions (% of total fuel combustion) of Resident buildings and public services in 1974 to that in 1976?
Your response must be concise. 0.83. What is the ratio of the CO2 emissions (% of total fuel combustion) of Other sectors in 1974 to that in 1977?
Give a very brief answer. 0.85. What is the ratio of the CO2 emissions (% of total fuel combustion) in Resident buildings and public services in 1974 to that in 1977?
Your answer should be compact. 0.88. What is the ratio of the CO2 emissions (% of total fuel combustion) in Transport in 1974 to that in 1977?
Your answer should be very brief. 1.03. What is the ratio of the CO2 emissions (% of total fuel combustion) of Other sectors in 1975 to that in 1976?
Your answer should be very brief. 1.03. What is the ratio of the CO2 emissions (% of total fuel combustion) in Resident buildings and public services in 1975 to that in 1976?
Give a very brief answer. 0.91. What is the ratio of the CO2 emissions (% of total fuel combustion) of Other sectors in 1975 to that in 1977?
Offer a very short reply. 0.82. What is the ratio of the CO2 emissions (% of total fuel combustion) in Resident buildings and public services in 1975 to that in 1977?
Offer a terse response. 0.97. What is the ratio of the CO2 emissions (% of total fuel combustion) of Transport in 1975 to that in 1977?
Make the answer very short. 1.04. What is the ratio of the CO2 emissions (% of total fuel combustion) in Other sectors in 1976 to that in 1977?
Provide a succinct answer. 0.8. What is the ratio of the CO2 emissions (% of total fuel combustion) of Resident buildings and public services in 1976 to that in 1977?
Your answer should be compact. 1.06. What is the ratio of the CO2 emissions (% of total fuel combustion) of Transport in 1976 to that in 1977?
Give a very brief answer. 1.04. What is the difference between the highest and the second highest CO2 emissions (% of total fuel combustion) in Other sectors?
Ensure brevity in your answer.  0.45. What is the difference between the highest and the second highest CO2 emissions (% of total fuel combustion) in Resident buildings and public services?
Offer a terse response. 0.64. What is the difference between the highest and the second highest CO2 emissions (% of total fuel combustion) in Transport?
Offer a terse response. 6.81. What is the difference between the highest and the lowest CO2 emissions (% of total fuel combustion) of Other sectors?
Offer a very short reply. 0.59. What is the difference between the highest and the lowest CO2 emissions (% of total fuel combustion) in Resident buildings and public services?
Provide a short and direct response. 1.52. What is the difference between the highest and the lowest CO2 emissions (% of total fuel combustion) in Transport?
Ensure brevity in your answer.  8.2. 